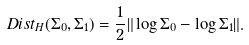Convert formula to latex. <formula><loc_0><loc_0><loc_500><loc_500>D i s t _ { H } ( \Sigma _ { 0 } , \Sigma _ { 1 } ) = \frac { 1 } { 2 } \| \log \Sigma _ { 0 } - \log \Sigma _ { 1 } \| .</formula> 